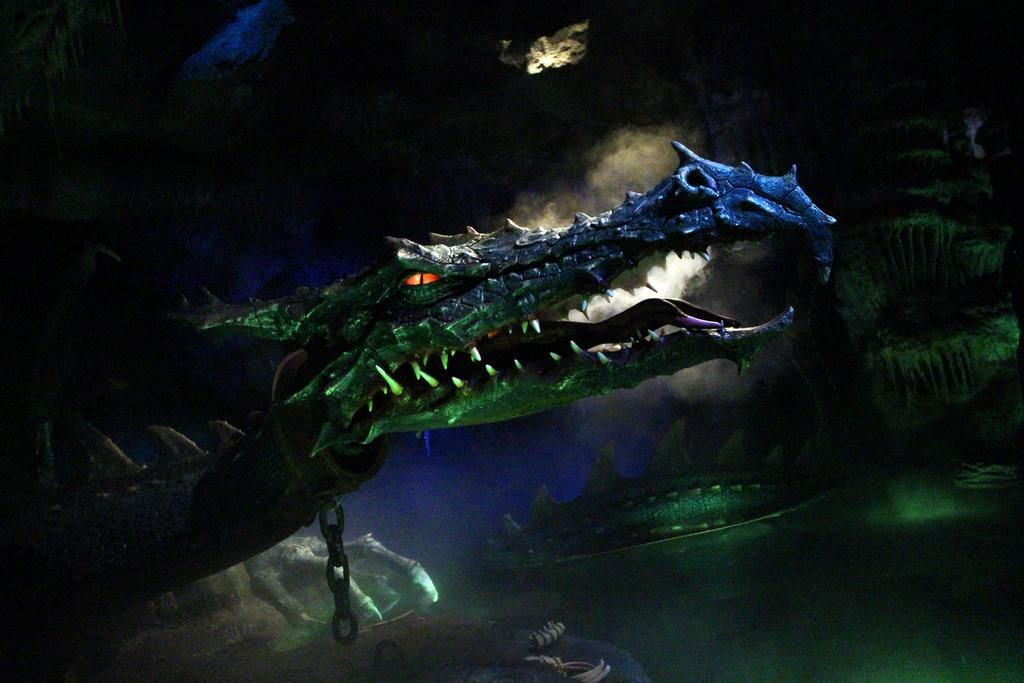What type of picture is the image? The image is an animated picture. What can be seen in the image? There are animals in the image. Can you describe the position of one of the animals in the image? One animal is tied with a chain on the left side of the image. What type of selection process is depicted in the image? There is no selection process depicted in the image; it features animals in an animated setting. Can you tell me how many gravestones are present in the image? There are no gravestones or cemetery elements present in the image. 